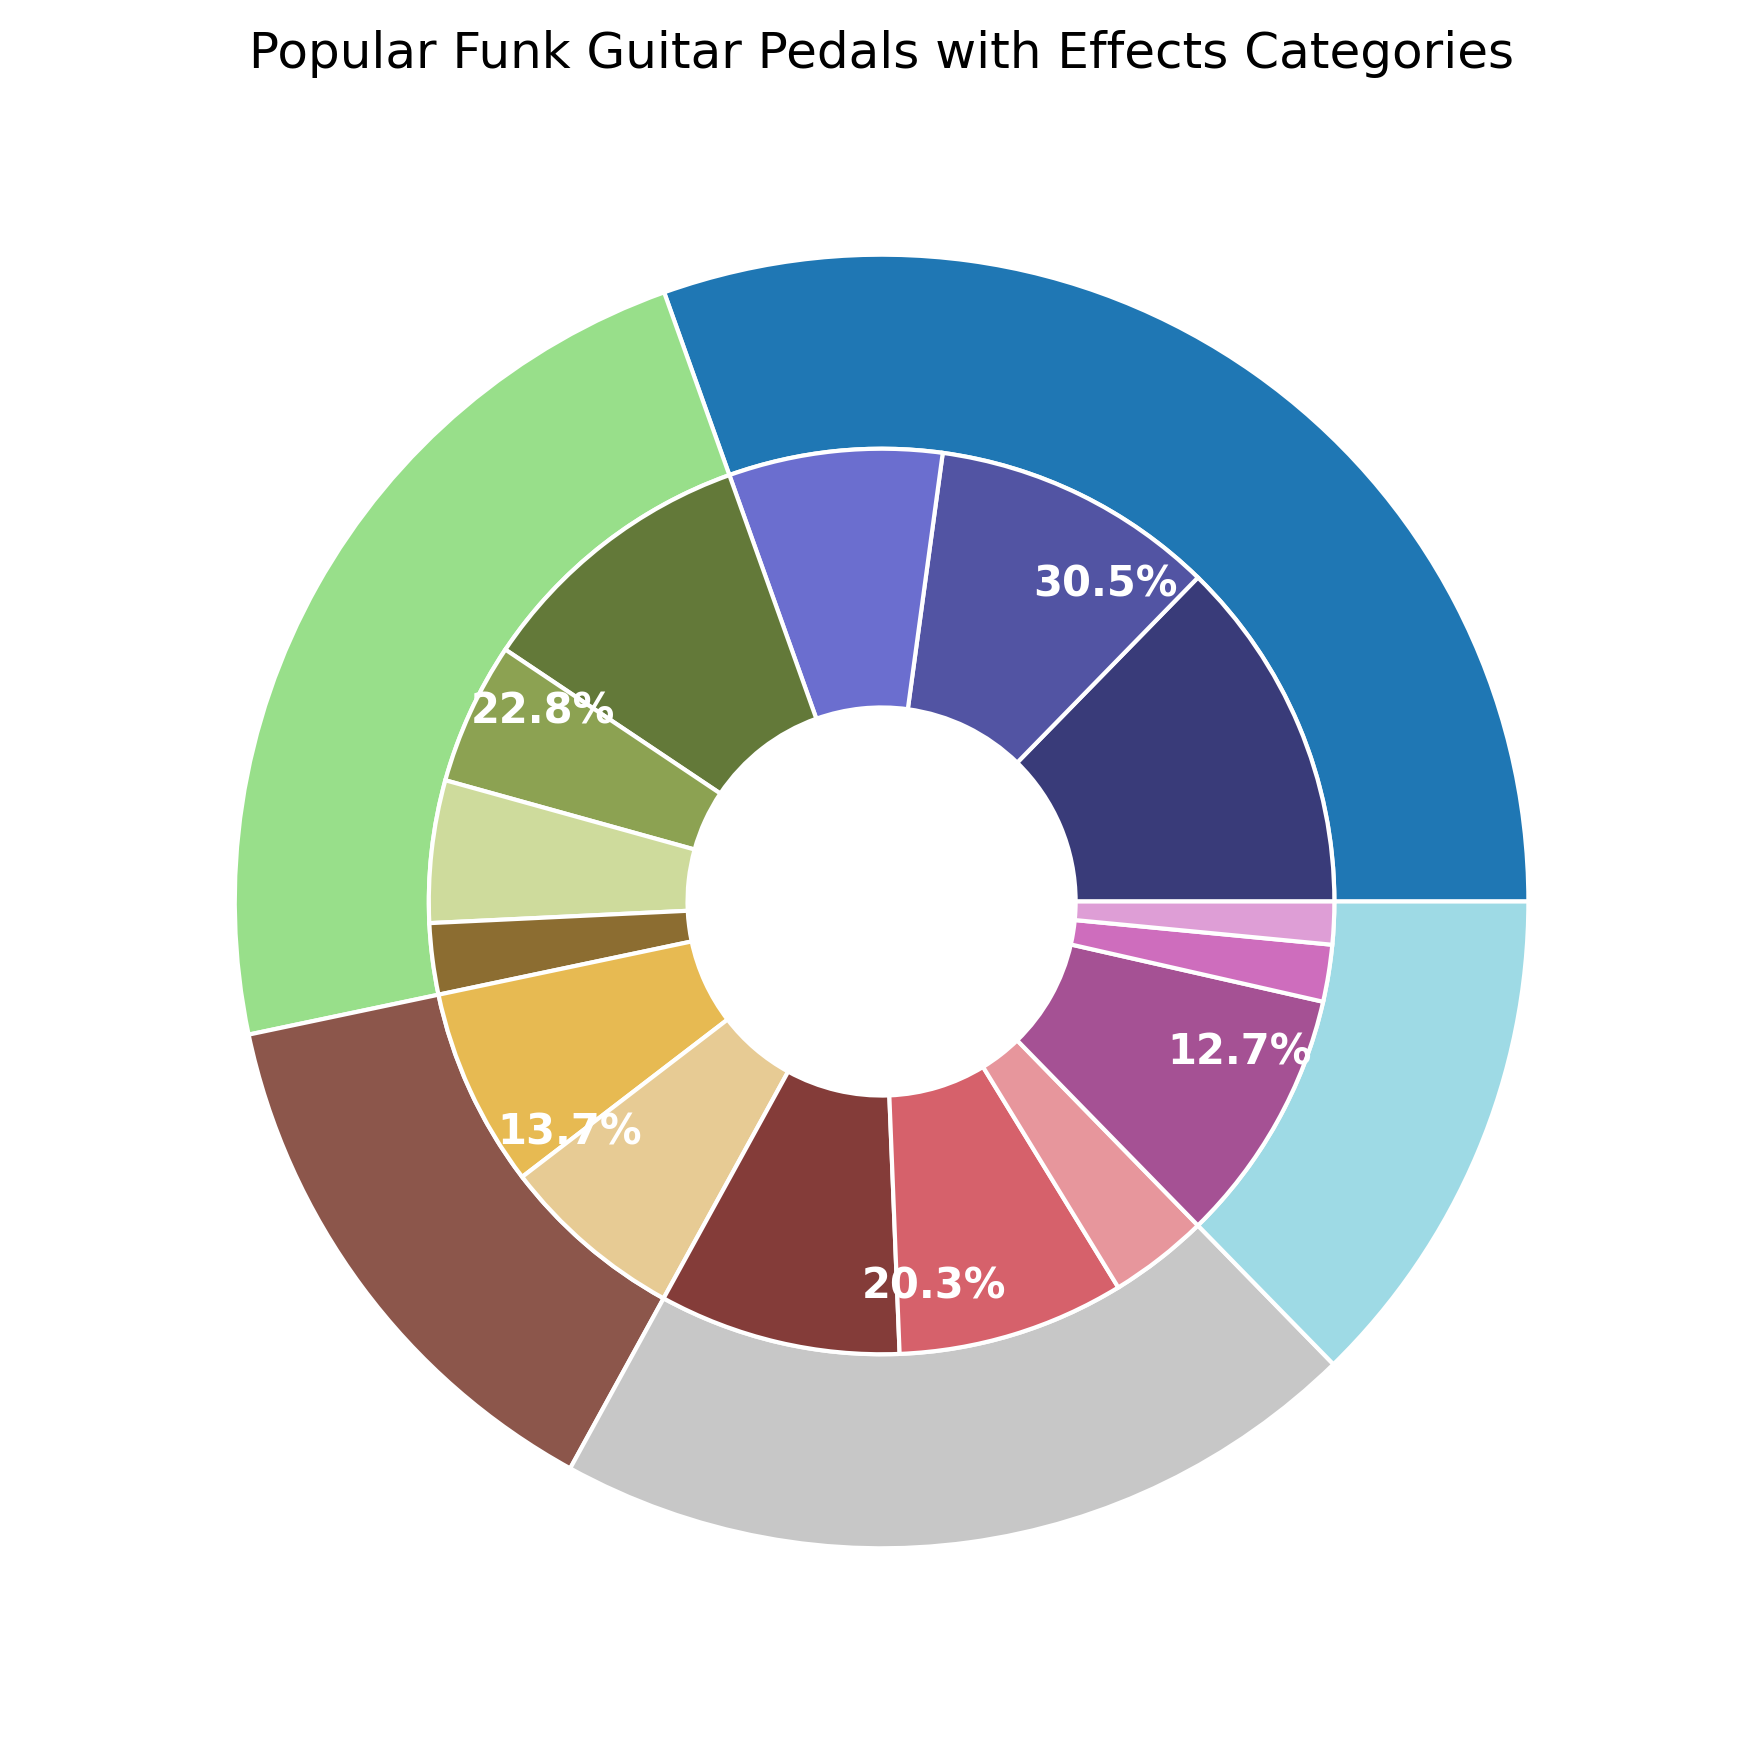Which category has the highest percentage in the figure? Looking at the outer pie chart, the largest section visually represents the Distortion category.
Answer: Distortion How much more popular is the Fuzz effect compared to the Compressor effect? Fuzz has a popularity of 25, and Compressor has a popularity of 18. So, 25 - 18 = 7 more popular.
Answer: 7 Which effect is the least popular overall? The smallest wedge in the inner pie chart represents the Noise Gate effect within the Dynamics category, which has a popularity of 3.
Answer: Noise Gate Which two categories have the closest popularity percentages, and what are they? By closely inspecting the outer pie chart, the Time-Based and Wah/Filter categories have closely matching sizes, occupying similar visual space. Their percentages are calculated as follows:
Time-Based: (14+13) / 183 * 100 = 14.21%
Wah/Filter: (17+16+7) / 183 * 100 = 21.31%
So they are 14.21% and 21.31%.
Answer: Time-Based and Wah/Filter What is the total popularity of effects in the Modulation category? Within the Modulation category, adding up the popularities of Chorus, Phaser, Flanger, and Uni-Vibe: 20 + 10 + 10 + 5 = 45.
Answer: 45 Which effect in the Modulation category is the most popular, and what is its popularity? In the inner pie chart within the Modulation wedge, the largest slice represents the Chorus effect.
Answer: Chorus, 20 How does the popularity of the Overdrive effect compare with the Envelope Filter effect? Overdrive has a popularity of 20 and Envelope Filter has a popularity of 16. So, Overdrive is more popular.
Answer: Overdrive What percentage of the total does the Distortion category contribute? Sum of Distortion effects' popularities: 25 + 20 + 15 = 60. Total popularity sum: 25+20+15+20+10+10+5+14+13+17+16+7+18+4+3 = 197. Distortion category percentage: 60/197 * 100 = 30.46%.
Answer: 30.46% Combine popularity numbers to find the total for the Wah/Filter and Dynamic categories. Wah/Filter total: 17 (Auto-Wah) + 16 (Envelope Filter) + 7 (Talk Box) = 40. Dynamic total: 18 (Compressor) + 4 (Limiter) + 3 (Noise Gate) = 25. Combined total: 40 + 25 = 65.
Answer: 65 Which effect categories have all their effects contributing less than 20 in popularity each? Checking the data, the Modulation effects (Chorus: 20, Phaser: 10, Flanger: 10, Uni-Vibe: 5), and Dynamic effects (Compressor: 18, Limiter: 4, Noise Gate: 3) all have individual effects with less than 20 popularity each.
Answer: Modulation, Dynamic 